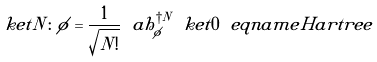Convert formula to latex. <formula><loc_0><loc_0><loc_500><loc_500>\ k e t { N \colon \phi } = \frac { 1 } { \sqrt { N ! } } \ a h _ { \phi } ^ { \dagger N } \ k e t { 0 } \ e q n a m e { H a r t r e e }</formula> 